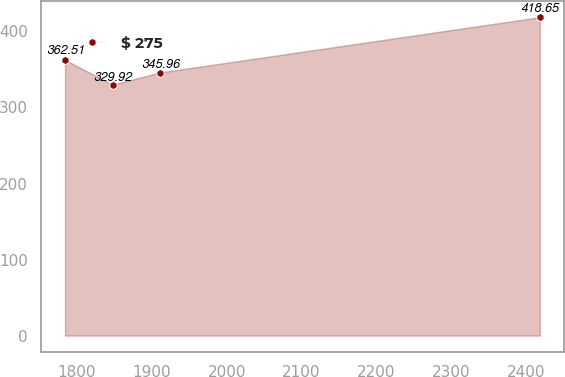Convert chart. <chart><loc_0><loc_0><loc_500><loc_500><line_chart><ecel><fcel>$ 275<nl><fcel>1783.97<fcel>362.51<nl><fcel>1847.43<fcel>329.92<nl><fcel>1910.89<fcel>345.96<nl><fcel>2418.53<fcel>418.65<nl></chart> 